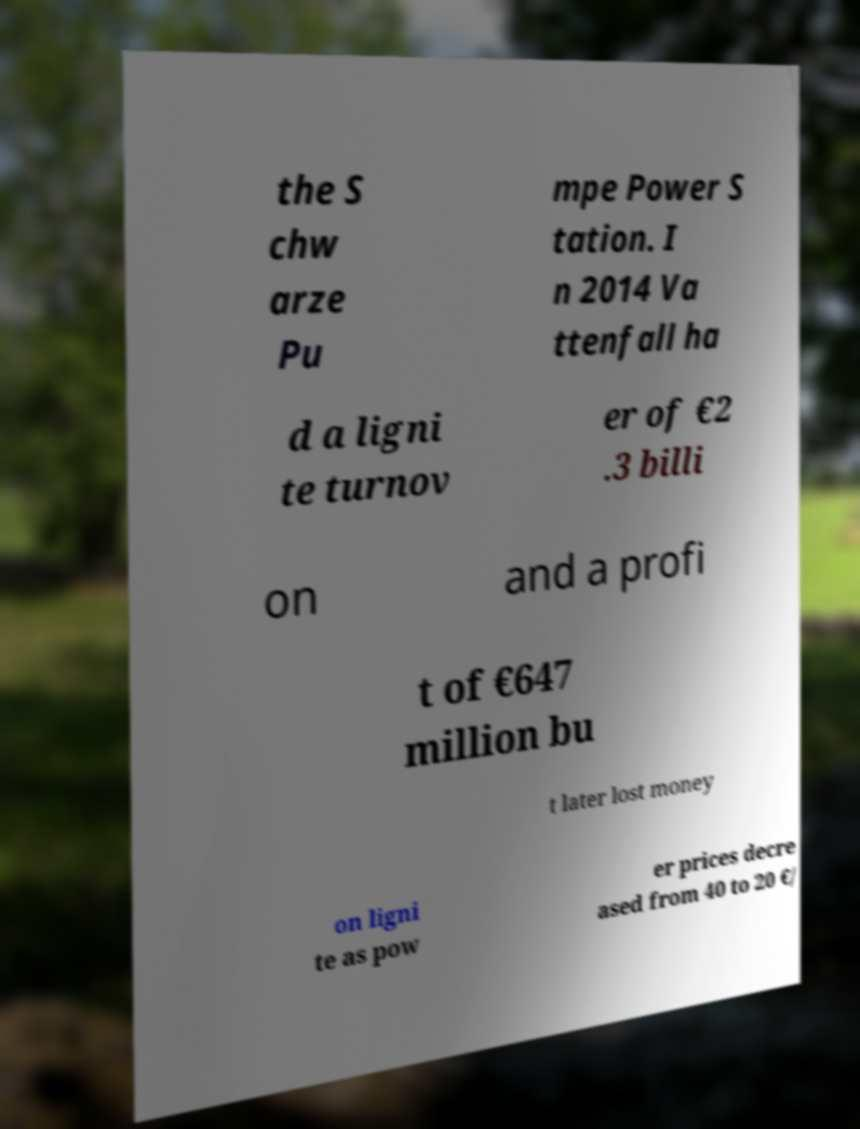Could you extract and type out the text from this image? the S chw arze Pu mpe Power S tation. I n 2014 Va ttenfall ha d a ligni te turnov er of €2 .3 billi on and a profi t of €647 million bu t later lost money on ligni te as pow er prices decre ased from 40 to 20 €/ 